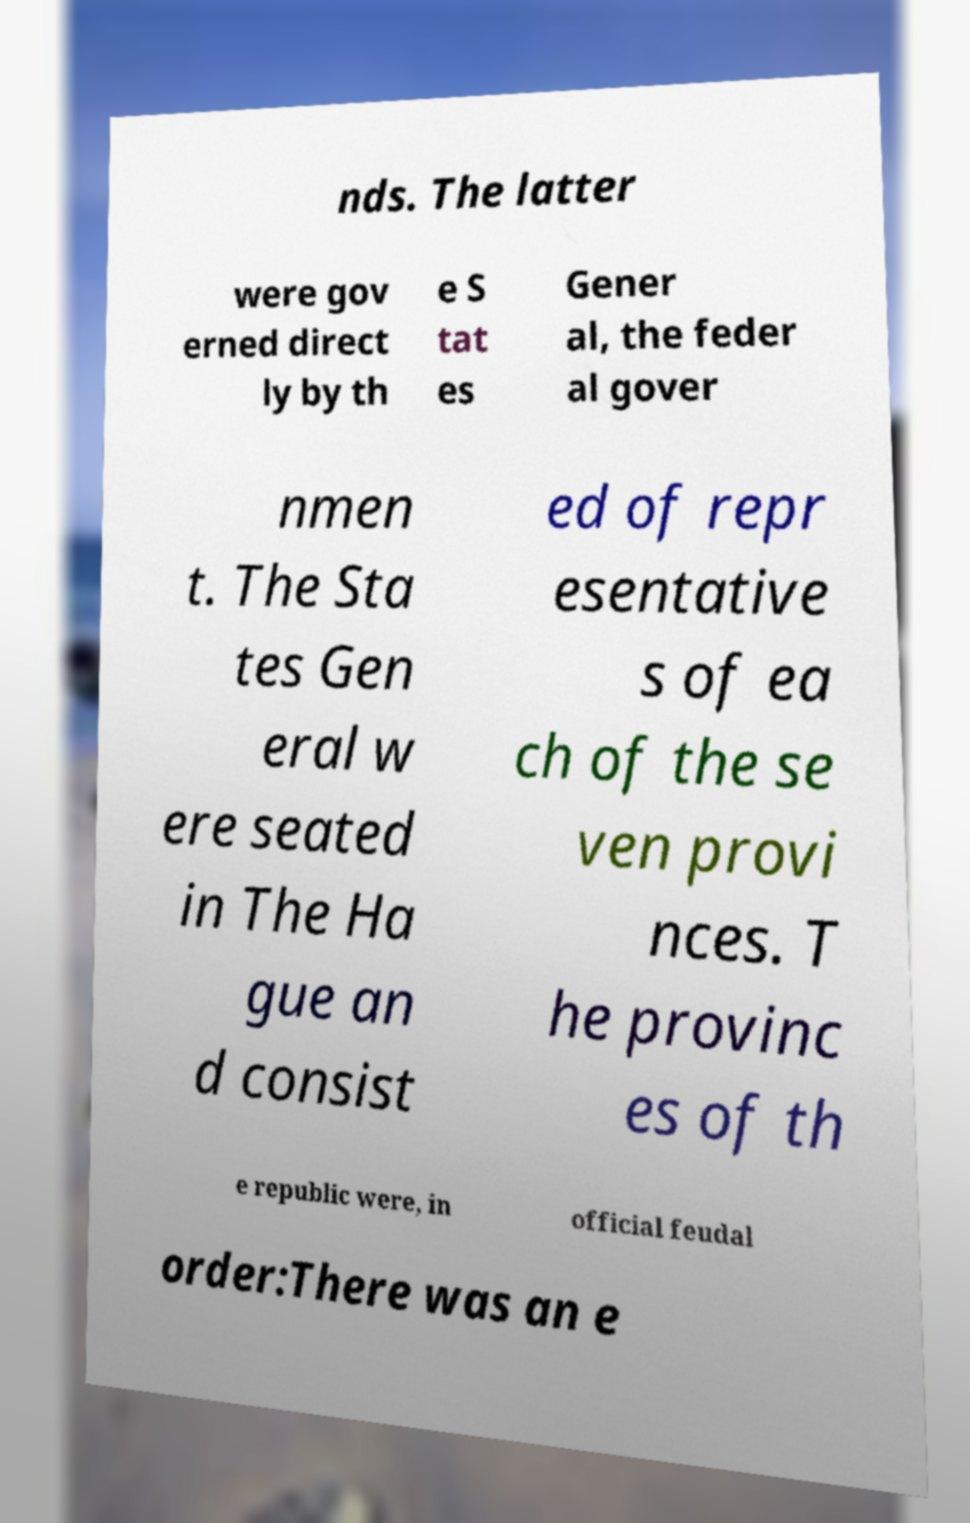Please identify and transcribe the text found in this image. nds. The latter were gov erned direct ly by th e S tat es Gener al, the feder al gover nmen t. The Sta tes Gen eral w ere seated in The Ha gue an d consist ed of repr esentative s of ea ch of the se ven provi nces. T he provinc es of th e republic were, in official feudal order:There was an e 